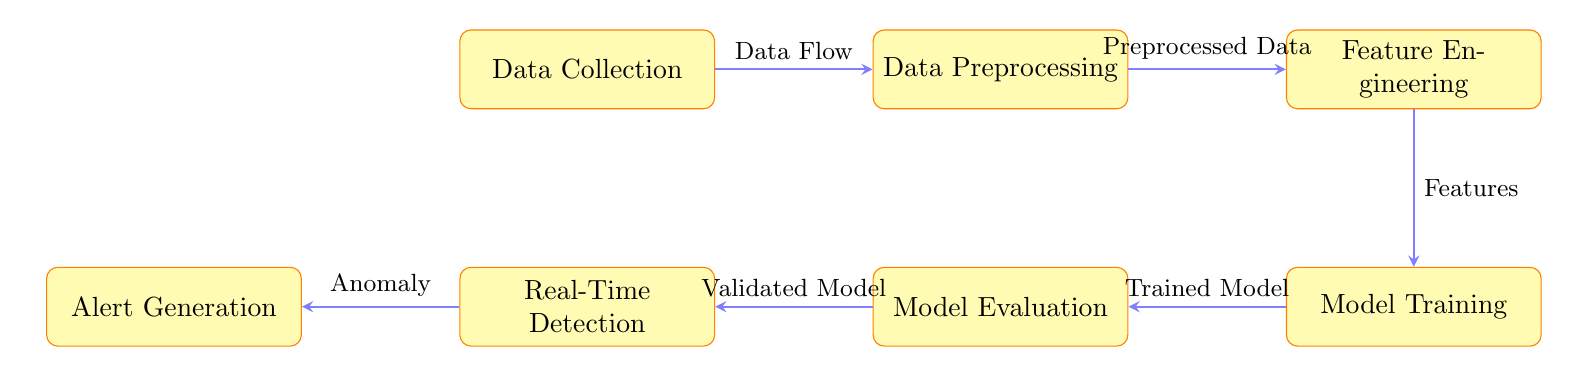What is the first step in the anomaly detection pipeline? The diagram indicates that the first step in the pipeline is "Data Collection", which is represented at the far left of the diagram.
Answer: Data Collection How many main processes are shown in the diagram? Counting the rectangles in the diagram, there are a total of six processes: Data Collection, Data Preprocessing, Feature Engineering, Model Training, Model Evaluation, Real-Time Detection, and Alert Generation.
Answer: Six What is the last step before alert generation? In the diagram, the process that occurs directly before Alert Generation is "Real-Time Detection", as indicated by the arrow connecting these two processes.
Answer: Real-Time Detection What type of data flows from "Feature Engineering" to "Model Training"? The diagram specifies that the type of data transitioning from "Feature Engineering" to "Model Training" is "Features", as labeled on the arrow connecting these two nodes.
Answer: Features What is the relationship between "Model Evaluation" and "Real-Time Detection"? The diagram shows that the output of "Model Evaluation" feeds into "Real-Time Detection", indicating a sequential relationship where the validated model is used for real-time anomaly detection.
Answer: Sequential relationship What does the diagram imply is the output of "Model Training"? The arrow leading from "Model Training" to "Model Evaluation" is labeled "Trained Model", indicating that the output of the model training step is the trained model utilized in model evaluation.
Answer: Trained Model How many arrows are present in the diagram illustrating data flow? By counting the arrows, there are a total of five arrows in the diagram, which represent the flow of data from one process to another.
Answer: Five What type of output is expected from "Real-Time Detection"? According to the diagram, the output generated from "Real-Time Detection" is referred to as "Anomaly", which is shown in the arrow leading to the next process.
Answer: Anomaly 